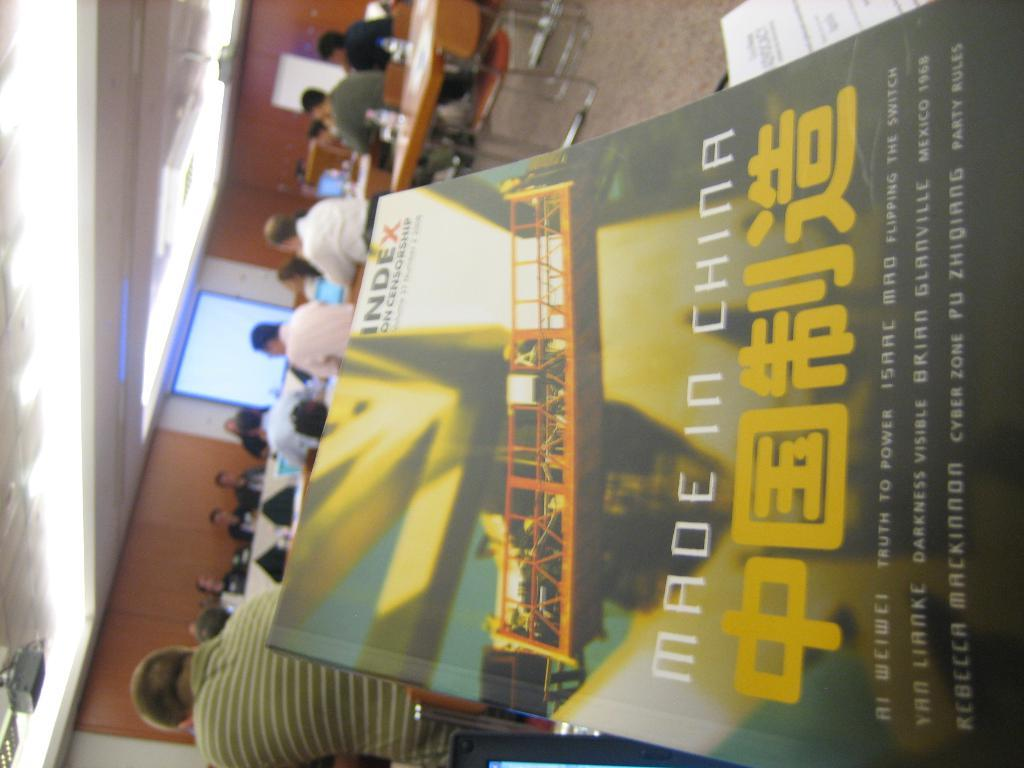<image>
Summarize the visual content of the image. The book shown with chinese writing on the cover was made in China. 